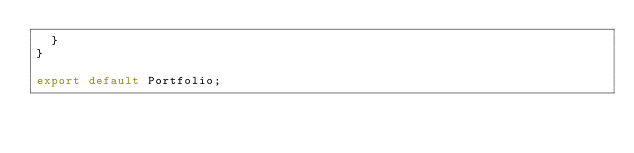<code> <loc_0><loc_0><loc_500><loc_500><_JavaScript_>  }
}

export default Portfolio;
</code> 